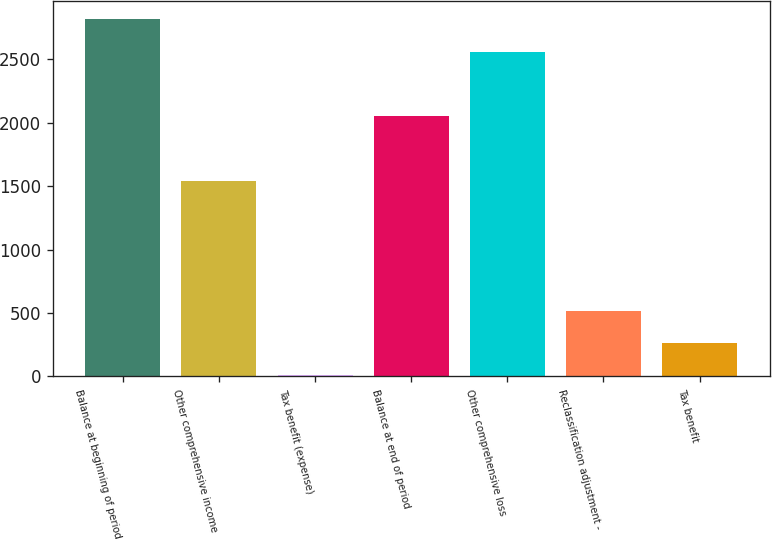<chart> <loc_0><loc_0><loc_500><loc_500><bar_chart><fcel>Balance at beginning of period<fcel>Other comprehensive income<fcel>Tax benefit (expense)<fcel>Balance at end of period<fcel>Other comprehensive loss<fcel>Reclassification adjustment -<fcel>Tax benefit<nl><fcel>2817.4<fcel>1540.4<fcel>8<fcel>2051.2<fcel>2562<fcel>518.8<fcel>263.4<nl></chart> 